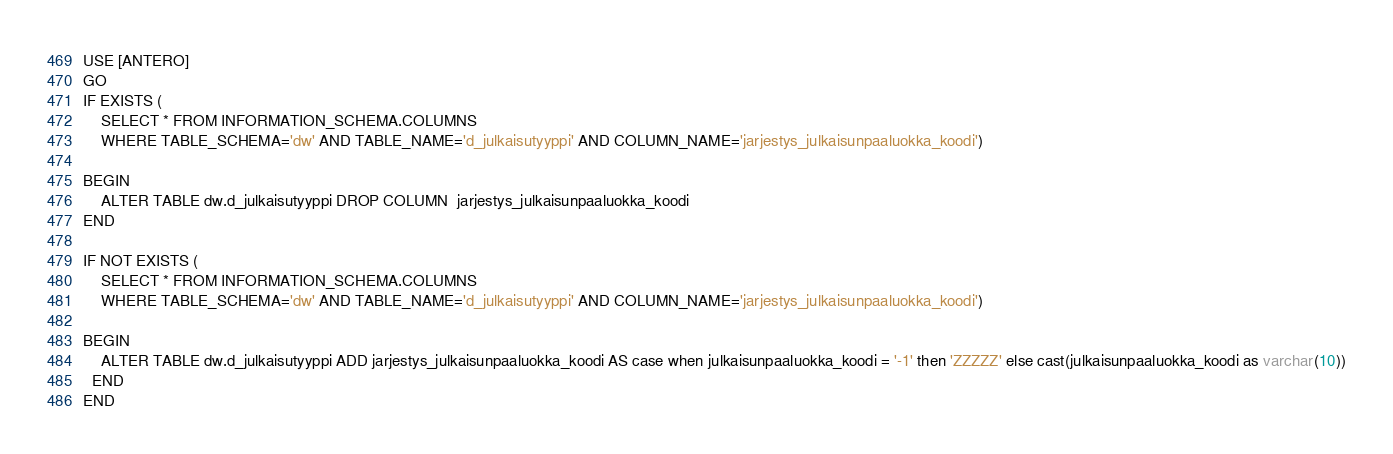<code> <loc_0><loc_0><loc_500><loc_500><_SQL_>USE [ANTERO]
GO
IF EXISTS (
	SELECT * FROM INFORMATION_SCHEMA.COLUMNS
	WHERE TABLE_SCHEMA='dw' AND TABLE_NAME='d_julkaisutyyppi' AND COLUMN_NAME='jarjestys_julkaisunpaaluokka_koodi')

BEGIN
	ALTER TABLE dw.d_julkaisutyyppi DROP COLUMN  jarjestys_julkaisunpaaluokka_koodi
END

IF NOT EXISTS (
	SELECT * FROM INFORMATION_SCHEMA.COLUMNS
	WHERE TABLE_SCHEMA='dw' AND TABLE_NAME='d_julkaisutyyppi' AND COLUMN_NAME='jarjestys_julkaisunpaaluokka_koodi')

BEGIN
	ALTER TABLE dw.d_julkaisutyyppi ADD jarjestys_julkaisunpaaluokka_koodi AS case when julkaisunpaaluokka_koodi = '-1' then 'ZZZZZ' else cast(julkaisunpaaluokka_koodi as varchar(10))
  END
END
</code> 